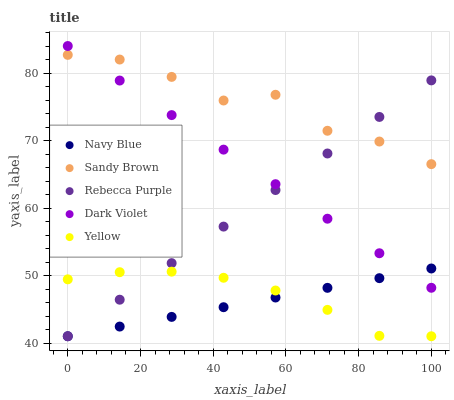Does Navy Blue have the minimum area under the curve?
Answer yes or no. Yes. Does Sandy Brown have the maximum area under the curve?
Answer yes or no. Yes. Does Yellow have the minimum area under the curve?
Answer yes or no. No. Does Yellow have the maximum area under the curve?
Answer yes or no. No. Is Navy Blue the smoothest?
Answer yes or no. Yes. Is Sandy Brown the roughest?
Answer yes or no. Yes. Is Yellow the smoothest?
Answer yes or no. No. Is Yellow the roughest?
Answer yes or no. No. Does Navy Blue have the lowest value?
Answer yes or no. Yes. Does Sandy Brown have the lowest value?
Answer yes or no. No. Does Dark Violet have the highest value?
Answer yes or no. Yes. Does Sandy Brown have the highest value?
Answer yes or no. No. Is Yellow less than Sandy Brown?
Answer yes or no. Yes. Is Sandy Brown greater than Navy Blue?
Answer yes or no. Yes. Does Navy Blue intersect Yellow?
Answer yes or no. Yes. Is Navy Blue less than Yellow?
Answer yes or no. No. Is Navy Blue greater than Yellow?
Answer yes or no. No. Does Yellow intersect Sandy Brown?
Answer yes or no. No. 